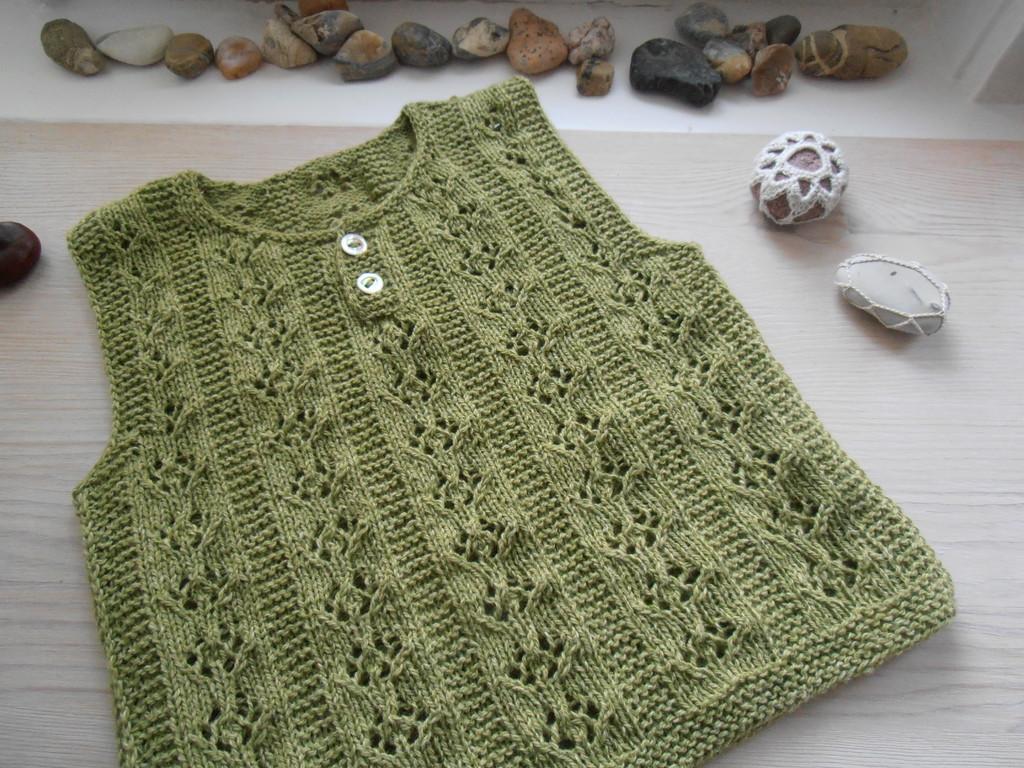Could you give a brief overview of what you see in this image? In this image I can see the green color dress on the table. To the side there are colorful rocks and I can see the woolen cloth is covered to one of the cloth. 